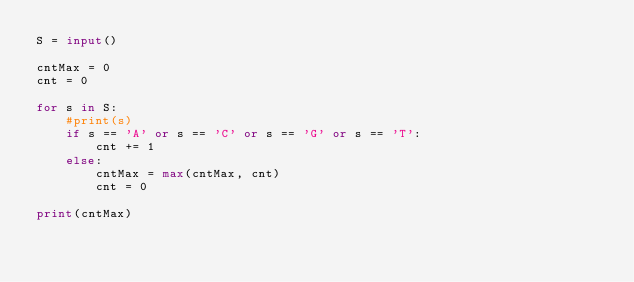<code> <loc_0><loc_0><loc_500><loc_500><_Python_>S = input()

cntMax = 0
cnt = 0

for s in S:
    #print(s)
    if s == 'A' or s == 'C' or s == 'G' or s == 'T':
        cnt += 1
    else:
        cntMax = max(cntMax, cnt)
        cnt = 0

print(cntMax)</code> 